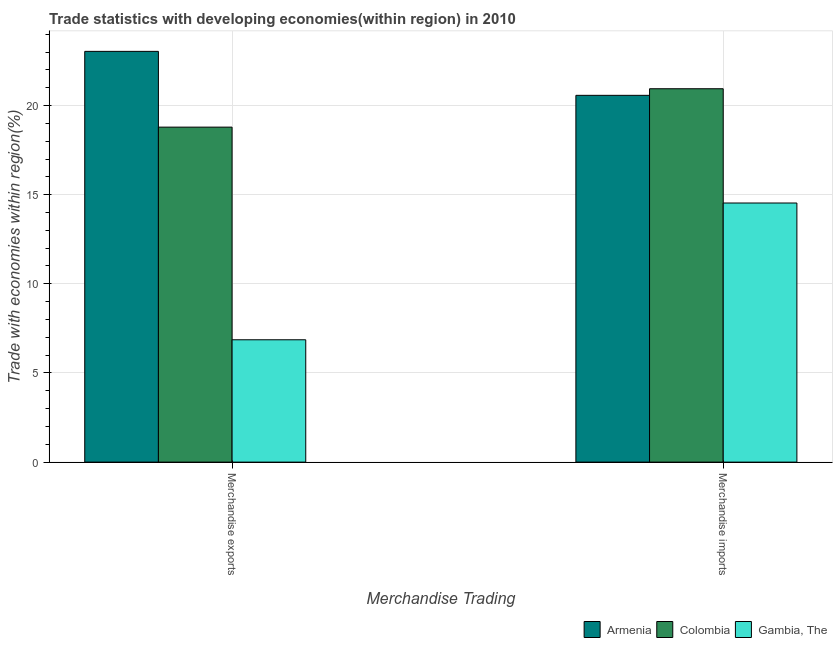How many different coloured bars are there?
Ensure brevity in your answer.  3. How many groups of bars are there?
Provide a short and direct response. 2. How many bars are there on the 2nd tick from the left?
Ensure brevity in your answer.  3. How many bars are there on the 1st tick from the right?
Provide a succinct answer. 3. What is the merchandise imports in Colombia?
Make the answer very short. 20.94. Across all countries, what is the maximum merchandise exports?
Your answer should be very brief. 23.04. Across all countries, what is the minimum merchandise imports?
Offer a terse response. 14.53. In which country was the merchandise exports minimum?
Ensure brevity in your answer.  Gambia, The. What is the total merchandise exports in the graph?
Ensure brevity in your answer.  48.69. What is the difference between the merchandise exports in Gambia, The and that in Colombia?
Keep it short and to the point. -11.93. What is the difference between the merchandise exports in Colombia and the merchandise imports in Armenia?
Provide a succinct answer. -1.78. What is the average merchandise imports per country?
Keep it short and to the point. 18.68. What is the difference between the merchandise imports and merchandise exports in Colombia?
Your answer should be very brief. 2.15. In how many countries, is the merchandise exports greater than 18 %?
Offer a very short reply. 2. What is the ratio of the merchandise exports in Colombia to that in Armenia?
Provide a succinct answer. 0.82. In how many countries, is the merchandise imports greater than the average merchandise imports taken over all countries?
Offer a terse response. 2. What does the 1st bar from the left in Merchandise exports represents?
Provide a succinct answer. Armenia. What does the 1st bar from the right in Merchandise exports represents?
Keep it short and to the point. Gambia, The. Are the values on the major ticks of Y-axis written in scientific E-notation?
Ensure brevity in your answer.  No. What is the title of the graph?
Provide a succinct answer. Trade statistics with developing economies(within region) in 2010. Does "Equatorial Guinea" appear as one of the legend labels in the graph?
Ensure brevity in your answer.  No. What is the label or title of the X-axis?
Your answer should be compact. Merchandise Trading. What is the label or title of the Y-axis?
Your answer should be very brief. Trade with economies within region(%). What is the Trade with economies within region(%) in Armenia in Merchandise exports?
Your answer should be compact. 23.04. What is the Trade with economies within region(%) of Colombia in Merchandise exports?
Offer a very short reply. 18.79. What is the Trade with economies within region(%) of Gambia, The in Merchandise exports?
Provide a succinct answer. 6.86. What is the Trade with economies within region(%) in Armenia in Merchandise imports?
Your answer should be compact. 20.57. What is the Trade with economies within region(%) of Colombia in Merchandise imports?
Your response must be concise. 20.94. What is the Trade with economies within region(%) in Gambia, The in Merchandise imports?
Provide a succinct answer. 14.53. Across all Merchandise Trading, what is the maximum Trade with economies within region(%) in Armenia?
Offer a very short reply. 23.04. Across all Merchandise Trading, what is the maximum Trade with economies within region(%) of Colombia?
Provide a short and direct response. 20.94. Across all Merchandise Trading, what is the maximum Trade with economies within region(%) in Gambia, The?
Your response must be concise. 14.53. Across all Merchandise Trading, what is the minimum Trade with economies within region(%) of Armenia?
Ensure brevity in your answer.  20.57. Across all Merchandise Trading, what is the minimum Trade with economies within region(%) of Colombia?
Give a very brief answer. 18.79. Across all Merchandise Trading, what is the minimum Trade with economies within region(%) of Gambia, The?
Your answer should be very brief. 6.86. What is the total Trade with economies within region(%) of Armenia in the graph?
Keep it short and to the point. 43.61. What is the total Trade with economies within region(%) in Colombia in the graph?
Your answer should be compact. 39.73. What is the total Trade with economies within region(%) of Gambia, The in the graph?
Provide a short and direct response. 21.39. What is the difference between the Trade with economies within region(%) in Armenia in Merchandise exports and that in Merchandise imports?
Offer a very short reply. 2.47. What is the difference between the Trade with economies within region(%) of Colombia in Merchandise exports and that in Merchandise imports?
Your answer should be compact. -2.15. What is the difference between the Trade with economies within region(%) of Gambia, The in Merchandise exports and that in Merchandise imports?
Provide a succinct answer. -7.67. What is the difference between the Trade with economies within region(%) of Armenia in Merchandise exports and the Trade with economies within region(%) of Colombia in Merchandise imports?
Your answer should be very brief. 2.1. What is the difference between the Trade with economies within region(%) of Armenia in Merchandise exports and the Trade with economies within region(%) of Gambia, The in Merchandise imports?
Make the answer very short. 8.5. What is the difference between the Trade with economies within region(%) in Colombia in Merchandise exports and the Trade with economies within region(%) in Gambia, The in Merchandise imports?
Ensure brevity in your answer.  4.25. What is the average Trade with economies within region(%) in Armenia per Merchandise Trading?
Make the answer very short. 21.8. What is the average Trade with economies within region(%) in Colombia per Merchandise Trading?
Give a very brief answer. 19.86. What is the average Trade with economies within region(%) of Gambia, The per Merchandise Trading?
Provide a short and direct response. 10.7. What is the difference between the Trade with economies within region(%) of Armenia and Trade with economies within region(%) of Colombia in Merchandise exports?
Your answer should be compact. 4.25. What is the difference between the Trade with economies within region(%) in Armenia and Trade with economies within region(%) in Gambia, The in Merchandise exports?
Your answer should be compact. 16.18. What is the difference between the Trade with economies within region(%) in Colombia and Trade with economies within region(%) in Gambia, The in Merchandise exports?
Offer a terse response. 11.93. What is the difference between the Trade with economies within region(%) of Armenia and Trade with economies within region(%) of Colombia in Merchandise imports?
Keep it short and to the point. -0.37. What is the difference between the Trade with economies within region(%) in Armenia and Trade with economies within region(%) in Gambia, The in Merchandise imports?
Your response must be concise. 6.04. What is the difference between the Trade with economies within region(%) in Colombia and Trade with economies within region(%) in Gambia, The in Merchandise imports?
Give a very brief answer. 6.41. What is the ratio of the Trade with economies within region(%) in Armenia in Merchandise exports to that in Merchandise imports?
Provide a succinct answer. 1.12. What is the ratio of the Trade with economies within region(%) of Colombia in Merchandise exports to that in Merchandise imports?
Keep it short and to the point. 0.9. What is the ratio of the Trade with economies within region(%) of Gambia, The in Merchandise exports to that in Merchandise imports?
Provide a succinct answer. 0.47. What is the difference between the highest and the second highest Trade with economies within region(%) in Armenia?
Offer a very short reply. 2.47. What is the difference between the highest and the second highest Trade with economies within region(%) in Colombia?
Ensure brevity in your answer.  2.15. What is the difference between the highest and the second highest Trade with economies within region(%) in Gambia, The?
Your response must be concise. 7.67. What is the difference between the highest and the lowest Trade with economies within region(%) in Armenia?
Your answer should be compact. 2.47. What is the difference between the highest and the lowest Trade with economies within region(%) in Colombia?
Your answer should be compact. 2.15. What is the difference between the highest and the lowest Trade with economies within region(%) in Gambia, The?
Offer a terse response. 7.67. 